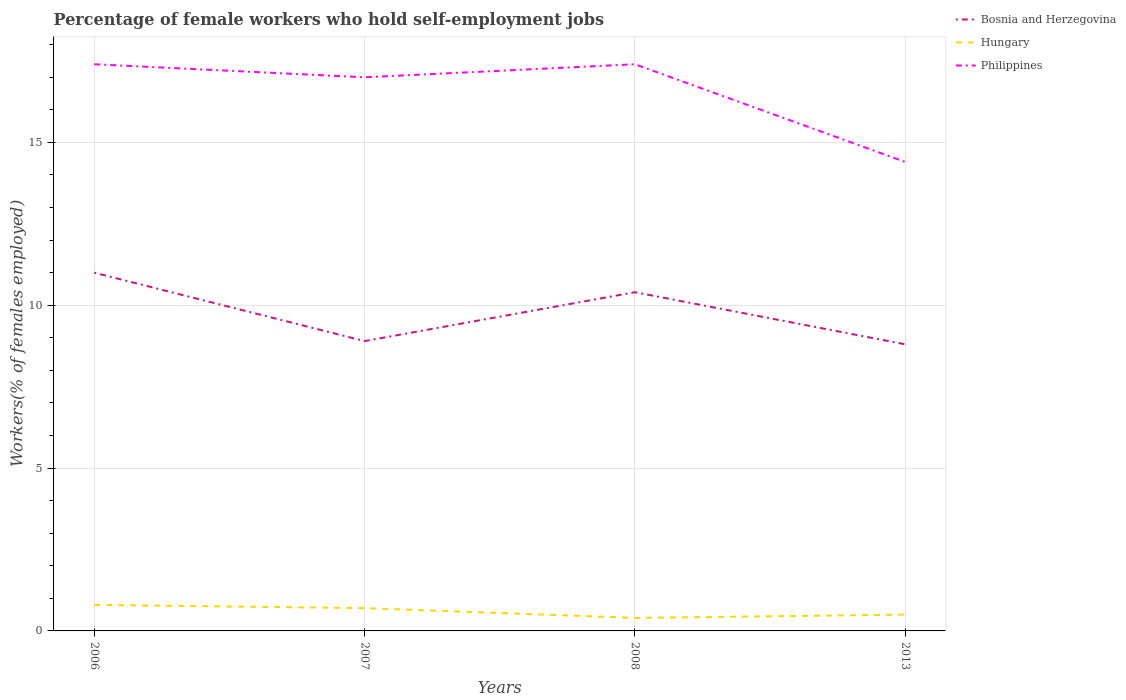Is the number of lines equal to the number of legend labels?
Ensure brevity in your answer.  Yes. Across all years, what is the maximum percentage of self-employed female workers in Bosnia and Herzegovina?
Your response must be concise. 8.8. What is the total percentage of self-employed female workers in Philippines in the graph?
Your answer should be very brief. 3. What is the difference between the highest and the second highest percentage of self-employed female workers in Hungary?
Ensure brevity in your answer.  0.4. What is the difference between the highest and the lowest percentage of self-employed female workers in Philippines?
Offer a very short reply. 3. How many years are there in the graph?
Ensure brevity in your answer.  4. What is the difference between two consecutive major ticks on the Y-axis?
Ensure brevity in your answer.  5. Does the graph contain any zero values?
Provide a succinct answer. No. How many legend labels are there?
Offer a terse response. 3. How are the legend labels stacked?
Provide a short and direct response. Vertical. What is the title of the graph?
Your answer should be very brief. Percentage of female workers who hold self-employment jobs. Does "Spain" appear as one of the legend labels in the graph?
Your answer should be compact. No. What is the label or title of the Y-axis?
Provide a short and direct response. Workers(% of females employed). What is the Workers(% of females employed) of Bosnia and Herzegovina in 2006?
Your answer should be very brief. 11. What is the Workers(% of females employed) of Hungary in 2006?
Provide a short and direct response. 0.8. What is the Workers(% of females employed) in Philippines in 2006?
Give a very brief answer. 17.4. What is the Workers(% of females employed) in Bosnia and Herzegovina in 2007?
Ensure brevity in your answer.  8.9. What is the Workers(% of females employed) in Hungary in 2007?
Your response must be concise. 0.7. What is the Workers(% of females employed) in Philippines in 2007?
Provide a succinct answer. 17. What is the Workers(% of females employed) in Bosnia and Herzegovina in 2008?
Offer a terse response. 10.4. What is the Workers(% of females employed) of Hungary in 2008?
Ensure brevity in your answer.  0.4. What is the Workers(% of females employed) of Philippines in 2008?
Your answer should be compact. 17.4. What is the Workers(% of females employed) in Bosnia and Herzegovina in 2013?
Offer a very short reply. 8.8. What is the Workers(% of females employed) of Hungary in 2013?
Provide a succinct answer. 0.5. What is the Workers(% of females employed) of Philippines in 2013?
Your answer should be very brief. 14.4. Across all years, what is the maximum Workers(% of females employed) in Bosnia and Herzegovina?
Provide a short and direct response. 11. Across all years, what is the maximum Workers(% of females employed) of Hungary?
Give a very brief answer. 0.8. Across all years, what is the maximum Workers(% of females employed) in Philippines?
Offer a terse response. 17.4. Across all years, what is the minimum Workers(% of females employed) of Bosnia and Herzegovina?
Offer a terse response. 8.8. Across all years, what is the minimum Workers(% of females employed) in Hungary?
Offer a very short reply. 0.4. Across all years, what is the minimum Workers(% of females employed) of Philippines?
Make the answer very short. 14.4. What is the total Workers(% of females employed) of Bosnia and Herzegovina in the graph?
Offer a very short reply. 39.1. What is the total Workers(% of females employed) of Hungary in the graph?
Your answer should be very brief. 2.4. What is the total Workers(% of females employed) in Philippines in the graph?
Your answer should be very brief. 66.2. What is the difference between the Workers(% of females employed) in Hungary in 2006 and that in 2007?
Offer a very short reply. 0.1. What is the difference between the Workers(% of females employed) in Hungary in 2006 and that in 2008?
Make the answer very short. 0.4. What is the difference between the Workers(% of females employed) of Philippines in 2006 and that in 2008?
Give a very brief answer. 0. What is the difference between the Workers(% of females employed) of Bosnia and Herzegovina in 2006 and that in 2013?
Your response must be concise. 2.2. What is the difference between the Workers(% of females employed) of Hungary in 2006 and that in 2013?
Provide a succinct answer. 0.3. What is the difference between the Workers(% of females employed) of Philippines in 2006 and that in 2013?
Keep it short and to the point. 3. What is the difference between the Workers(% of females employed) in Hungary in 2007 and that in 2008?
Offer a very short reply. 0.3. What is the difference between the Workers(% of females employed) of Hungary in 2007 and that in 2013?
Provide a short and direct response. 0.2. What is the difference between the Workers(% of females employed) of Philippines in 2007 and that in 2013?
Your answer should be very brief. 2.6. What is the difference between the Workers(% of females employed) of Bosnia and Herzegovina in 2008 and that in 2013?
Ensure brevity in your answer.  1.6. What is the difference between the Workers(% of females employed) of Hungary in 2008 and that in 2013?
Make the answer very short. -0.1. What is the difference between the Workers(% of females employed) of Bosnia and Herzegovina in 2006 and the Workers(% of females employed) of Hungary in 2007?
Keep it short and to the point. 10.3. What is the difference between the Workers(% of females employed) of Hungary in 2006 and the Workers(% of females employed) of Philippines in 2007?
Your answer should be very brief. -16.2. What is the difference between the Workers(% of females employed) in Bosnia and Herzegovina in 2006 and the Workers(% of females employed) in Hungary in 2008?
Provide a short and direct response. 10.6. What is the difference between the Workers(% of females employed) of Bosnia and Herzegovina in 2006 and the Workers(% of females employed) of Philippines in 2008?
Offer a terse response. -6.4. What is the difference between the Workers(% of females employed) of Hungary in 2006 and the Workers(% of females employed) of Philippines in 2008?
Give a very brief answer. -16.6. What is the difference between the Workers(% of females employed) of Bosnia and Herzegovina in 2007 and the Workers(% of females employed) of Hungary in 2008?
Provide a succinct answer. 8.5. What is the difference between the Workers(% of females employed) of Bosnia and Herzegovina in 2007 and the Workers(% of females employed) of Philippines in 2008?
Offer a very short reply. -8.5. What is the difference between the Workers(% of females employed) of Hungary in 2007 and the Workers(% of females employed) of Philippines in 2008?
Your answer should be compact. -16.7. What is the difference between the Workers(% of females employed) in Hungary in 2007 and the Workers(% of females employed) in Philippines in 2013?
Your answer should be very brief. -13.7. What is the difference between the Workers(% of females employed) of Bosnia and Herzegovina in 2008 and the Workers(% of females employed) of Hungary in 2013?
Your response must be concise. 9.9. What is the difference between the Workers(% of females employed) of Hungary in 2008 and the Workers(% of females employed) of Philippines in 2013?
Offer a terse response. -14. What is the average Workers(% of females employed) in Bosnia and Herzegovina per year?
Provide a short and direct response. 9.78. What is the average Workers(% of females employed) of Philippines per year?
Keep it short and to the point. 16.55. In the year 2006, what is the difference between the Workers(% of females employed) of Hungary and Workers(% of females employed) of Philippines?
Provide a short and direct response. -16.6. In the year 2007, what is the difference between the Workers(% of females employed) in Bosnia and Herzegovina and Workers(% of females employed) in Hungary?
Give a very brief answer. 8.2. In the year 2007, what is the difference between the Workers(% of females employed) of Hungary and Workers(% of females employed) of Philippines?
Provide a short and direct response. -16.3. In the year 2013, what is the difference between the Workers(% of females employed) in Bosnia and Herzegovina and Workers(% of females employed) in Philippines?
Keep it short and to the point. -5.6. In the year 2013, what is the difference between the Workers(% of females employed) of Hungary and Workers(% of females employed) of Philippines?
Your answer should be compact. -13.9. What is the ratio of the Workers(% of females employed) of Bosnia and Herzegovina in 2006 to that in 2007?
Ensure brevity in your answer.  1.24. What is the ratio of the Workers(% of females employed) in Hungary in 2006 to that in 2007?
Ensure brevity in your answer.  1.14. What is the ratio of the Workers(% of females employed) of Philippines in 2006 to that in 2007?
Give a very brief answer. 1.02. What is the ratio of the Workers(% of females employed) in Bosnia and Herzegovina in 2006 to that in 2008?
Offer a very short reply. 1.06. What is the ratio of the Workers(% of females employed) of Hungary in 2006 to that in 2008?
Offer a terse response. 2. What is the ratio of the Workers(% of females employed) in Philippines in 2006 to that in 2008?
Your response must be concise. 1. What is the ratio of the Workers(% of females employed) in Hungary in 2006 to that in 2013?
Your answer should be compact. 1.6. What is the ratio of the Workers(% of females employed) in Philippines in 2006 to that in 2013?
Your answer should be compact. 1.21. What is the ratio of the Workers(% of females employed) in Bosnia and Herzegovina in 2007 to that in 2008?
Offer a terse response. 0.86. What is the ratio of the Workers(% of females employed) of Bosnia and Herzegovina in 2007 to that in 2013?
Make the answer very short. 1.01. What is the ratio of the Workers(% of females employed) of Hungary in 2007 to that in 2013?
Give a very brief answer. 1.4. What is the ratio of the Workers(% of females employed) of Philippines in 2007 to that in 2013?
Keep it short and to the point. 1.18. What is the ratio of the Workers(% of females employed) of Bosnia and Herzegovina in 2008 to that in 2013?
Ensure brevity in your answer.  1.18. What is the ratio of the Workers(% of females employed) in Hungary in 2008 to that in 2013?
Provide a short and direct response. 0.8. What is the ratio of the Workers(% of females employed) of Philippines in 2008 to that in 2013?
Offer a very short reply. 1.21. What is the difference between the highest and the second highest Workers(% of females employed) of Hungary?
Ensure brevity in your answer.  0.1. What is the difference between the highest and the second highest Workers(% of females employed) of Philippines?
Make the answer very short. 0. What is the difference between the highest and the lowest Workers(% of females employed) of Bosnia and Herzegovina?
Ensure brevity in your answer.  2.2. What is the difference between the highest and the lowest Workers(% of females employed) in Hungary?
Your answer should be compact. 0.4. 